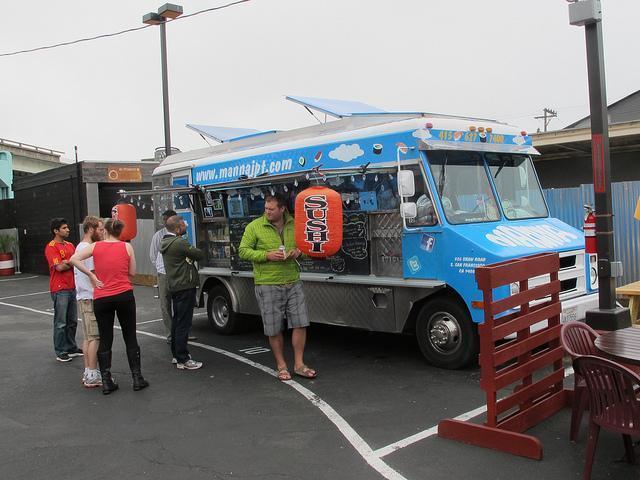How many people are in the photo?
Give a very brief answer. 6. How many people are there?
Give a very brief answer. 6. How many tires are visible?
Give a very brief answer. 2. How many food trucks are there?
Give a very brief answer. 1. How many people are wearing sandals?
Give a very brief answer. 1. How many people are wearing white outside of the truck?
Give a very brief answer. 2. How many men are wearing hats?
Give a very brief answer. 0. How many people are waiting?
Give a very brief answer. 6. How many zebras have stripes?
Give a very brief answer. 0. 